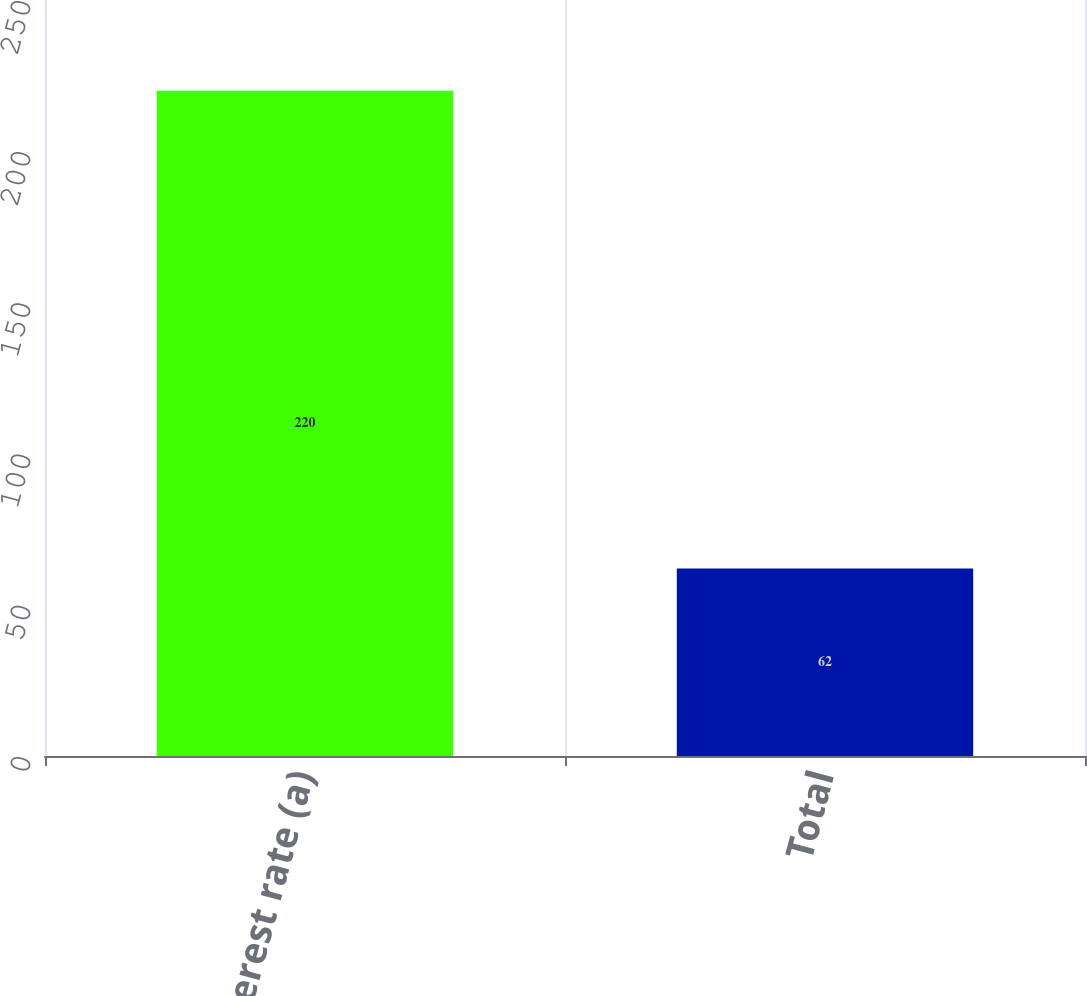Convert chart to OTSL. <chart><loc_0><loc_0><loc_500><loc_500><bar_chart><fcel>Interest rate (a)<fcel>Total<nl><fcel>220<fcel>62<nl></chart> 